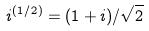Convert formula to latex. <formula><loc_0><loc_0><loc_500><loc_500>i ^ { ( 1 / 2 ) } = ( 1 + i ) / \sqrt { 2 }</formula> 